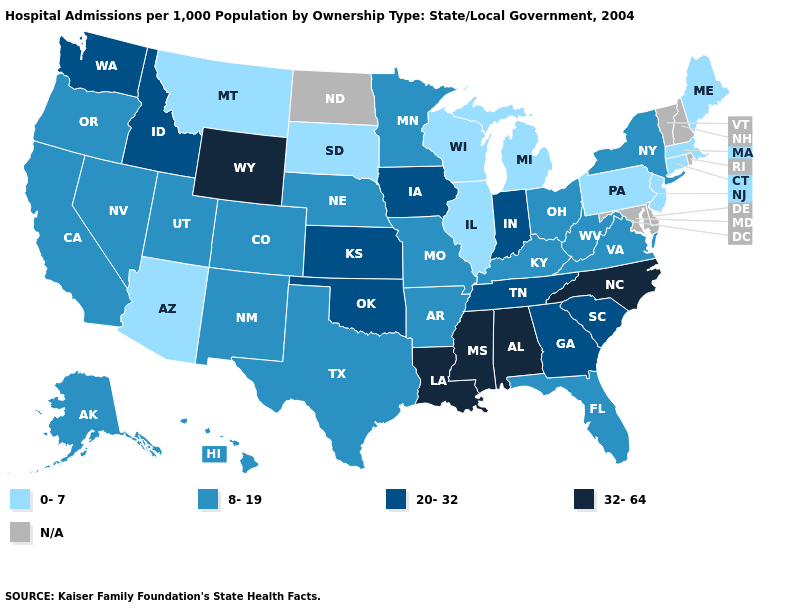Name the states that have a value in the range N/A?
Concise answer only. Delaware, Maryland, New Hampshire, North Dakota, Rhode Island, Vermont. Which states have the lowest value in the USA?
Write a very short answer. Arizona, Connecticut, Illinois, Maine, Massachusetts, Michigan, Montana, New Jersey, Pennsylvania, South Dakota, Wisconsin. What is the value of Oregon?
Give a very brief answer. 8-19. Does Louisiana have the highest value in the USA?
Concise answer only. Yes. What is the value of Mississippi?
Quick response, please. 32-64. Name the states that have a value in the range 20-32?
Short answer required. Georgia, Idaho, Indiana, Iowa, Kansas, Oklahoma, South Carolina, Tennessee, Washington. Among the states that border Nebraska , does Missouri have the highest value?
Keep it brief. No. Does Alaska have the lowest value in the West?
Short answer required. No. What is the value of Maryland?
Short answer required. N/A. Name the states that have a value in the range 0-7?
Give a very brief answer. Arizona, Connecticut, Illinois, Maine, Massachusetts, Michigan, Montana, New Jersey, Pennsylvania, South Dakota, Wisconsin. Name the states that have a value in the range 20-32?
Be succinct. Georgia, Idaho, Indiana, Iowa, Kansas, Oklahoma, South Carolina, Tennessee, Washington. Does Pennsylvania have the lowest value in the USA?
Write a very short answer. Yes. What is the value of Arizona?
Quick response, please. 0-7. What is the lowest value in states that border Iowa?
Keep it brief. 0-7. 